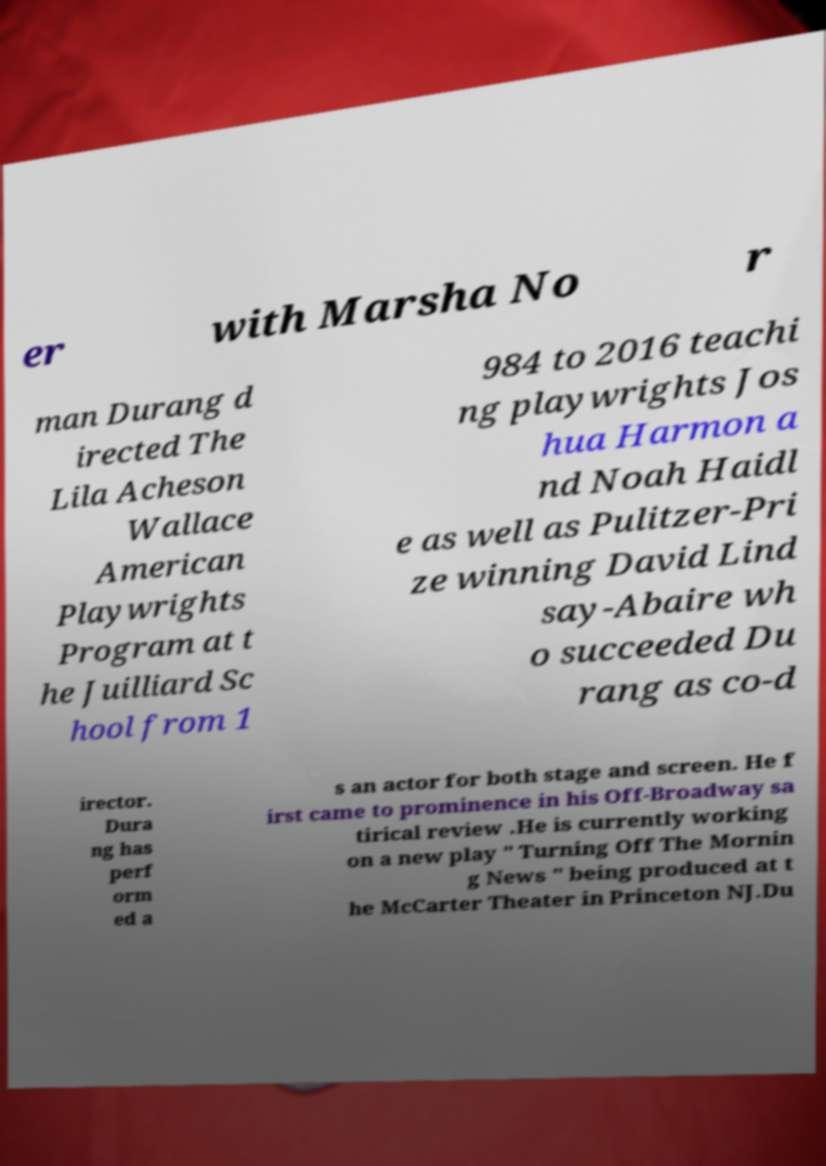Can you read and provide the text displayed in the image?This photo seems to have some interesting text. Can you extract and type it out for me? er with Marsha No r man Durang d irected The Lila Acheson Wallace American Playwrights Program at t he Juilliard Sc hool from 1 984 to 2016 teachi ng playwrights Jos hua Harmon a nd Noah Haidl e as well as Pulitzer-Pri ze winning David Lind say-Abaire wh o succeeded Du rang as co-d irector. Dura ng has perf orm ed a s an actor for both stage and screen. He f irst came to prominence in his Off-Broadway sa tirical review .He is currently working on a new play " Turning Off The Mornin g News " being produced at t he McCarter Theater in Princeton NJ.Du 